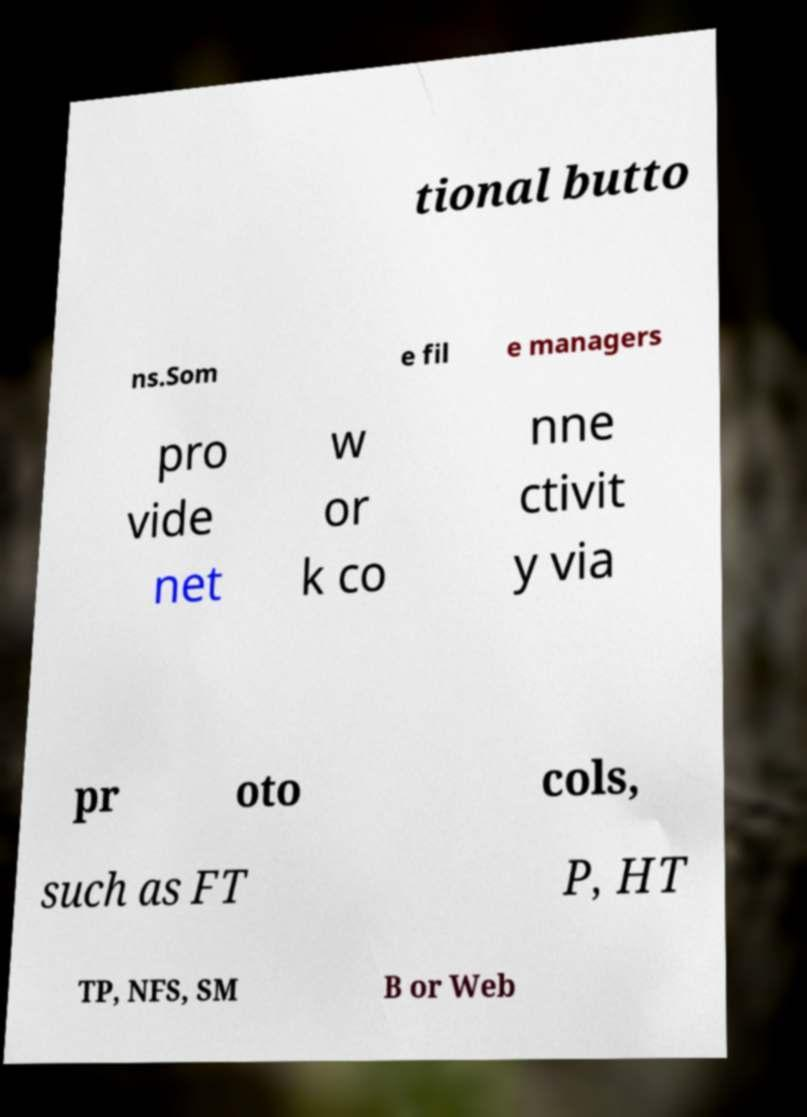Can you read and provide the text displayed in the image?This photo seems to have some interesting text. Can you extract and type it out for me? tional butto ns.Som e fil e managers pro vide net w or k co nne ctivit y via pr oto cols, such as FT P, HT TP, NFS, SM B or Web 